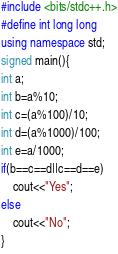Convert code to text. <code><loc_0><loc_0><loc_500><loc_500><_C++_>#include <bits/stdc++.h>
#define int long long
using namespace std;
signed main(){
int a;
int b=a%10;
int c=(a%100)/10;
int d=(a%1000)/100;
int e=a/1000;
if(b==c==d||c==d==e)
	cout<<"Yes";
else
	cout<<"No";
}</code> 